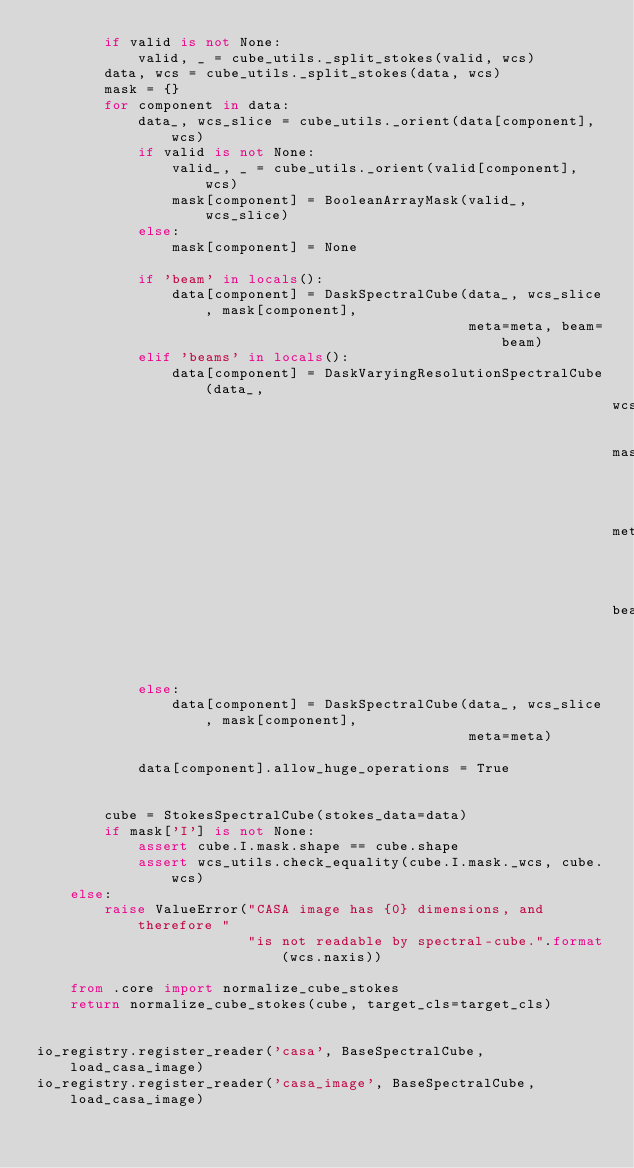<code> <loc_0><loc_0><loc_500><loc_500><_Python_>        if valid is not None:
            valid, _ = cube_utils._split_stokes(valid, wcs)
        data, wcs = cube_utils._split_stokes(data, wcs)
        mask = {}
        for component in data:
            data_, wcs_slice = cube_utils._orient(data[component], wcs)
            if valid is not None:
                valid_, _ = cube_utils._orient(valid[component], wcs)
                mask[component] = BooleanArrayMask(valid_, wcs_slice)
            else:
                mask[component] = None

            if 'beam' in locals():
                data[component] = DaskSpectralCube(data_, wcs_slice, mask[component],
                                                   meta=meta, beam=beam)
            elif 'beams' in locals():
                data[component] = DaskVaryingResolutionSpectralCube(data_,
                                                                    wcs_slice,
                                                                    mask[component],
                                                                    meta=meta,
                                                                    beams=beams)
            else:
                data[component] = DaskSpectralCube(data_, wcs_slice, mask[component],
                                                   meta=meta)

            data[component].allow_huge_operations = True


        cube = StokesSpectralCube(stokes_data=data)
        if mask['I'] is not None:
            assert cube.I.mask.shape == cube.shape
            assert wcs_utils.check_equality(cube.I.mask._wcs, cube.wcs)
    else:
        raise ValueError("CASA image has {0} dimensions, and therefore "
                         "is not readable by spectral-cube.".format(wcs.naxis))

    from .core import normalize_cube_stokes
    return normalize_cube_stokes(cube, target_cls=target_cls)


io_registry.register_reader('casa', BaseSpectralCube, load_casa_image)
io_registry.register_reader('casa_image', BaseSpectralCube, load_casa_image)</code> 